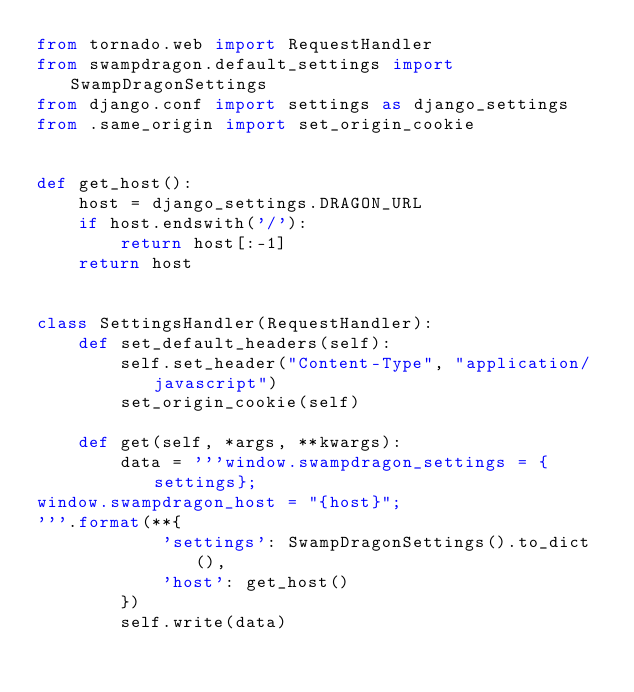Convert code to text. <code><loc_0><loc_0><loc_500><loc_500><_Python_>from tornado.web import RequestHandler
from swampdragon.default_settings import SwampDragonSettings
from django.conf import settings as django_settings
from .same_origin import set_origin_cookie


def get_host():
    host = django_settings.DRAGON_URL
    if host.endswith('/'):
        return host[:-1]
    return host


class SettingsHandler(RequestHandler):
    def set_default_headers(self):
        self.set_header("Content-Type", "application/javascript")
        set_origin_cookie(self)

    def get(self, *args, **kwargs):
        data = '''window.swampdragon_settings = {settings};
window.swampdragon_host = "{host}";
'''.format(**{
            'settings': SwampDragonSettings().to_dict(),
            'host': get_host()
        })
        self.write(data)
</code> 